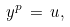<formula> <loc_0><loc_0><loc_500><loc_500>y ^ { p } \, = \, u ,</formula> 